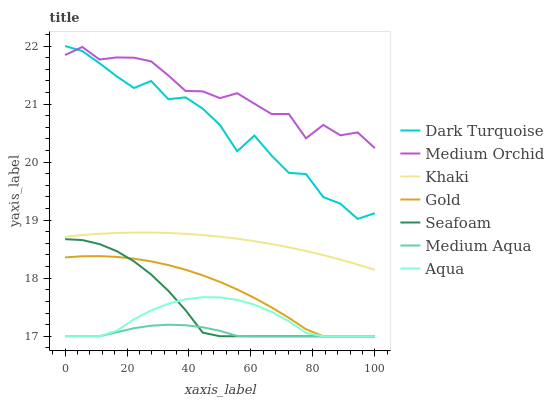Does Medium Aqua have the minimum area under the curve?
Answer yes or no. Yes. Does Medium Orchid have the maximum area under the curve?
Answer yes or no. Yes. Does Gold have the minimum area under the curve?
Answer yes or no. No. Does Gold have the maximum area under the curve?
Answer yes or no. No. Is Khaki the smoothest?
Answer yes or no. Yes. Is Dark Turquoise the roughest?
Answer yes or no. Yes. Is Gold the smoothest?
Answer yes or no. No. Is Gold the roughest?
Answer yes or no. No. Does Gold have the lowest value?
Answer yes or no. Yes. Does Dark Turquoise have the lowest value?
Answer yes or no. No. Does Dark Turquoise have the highest value?
Answer yes or no. Yes. Does Gold have the highest value?
Answer yes or no. No. Is Aqua less than Khaki?
Answer yes or no. Yes. Is Medium Orchid greater than Aqua?
Answer yes or no. Yes. Does Aqua intersect Gold?
Answer yes or no. Yes. Is Aqua less than Gold?
Answer yes or no. No. Is Aqua greater than Gold?
Answer yes or no. No. Does Aqua intersect Khaki?
Answer yes or no. No. 